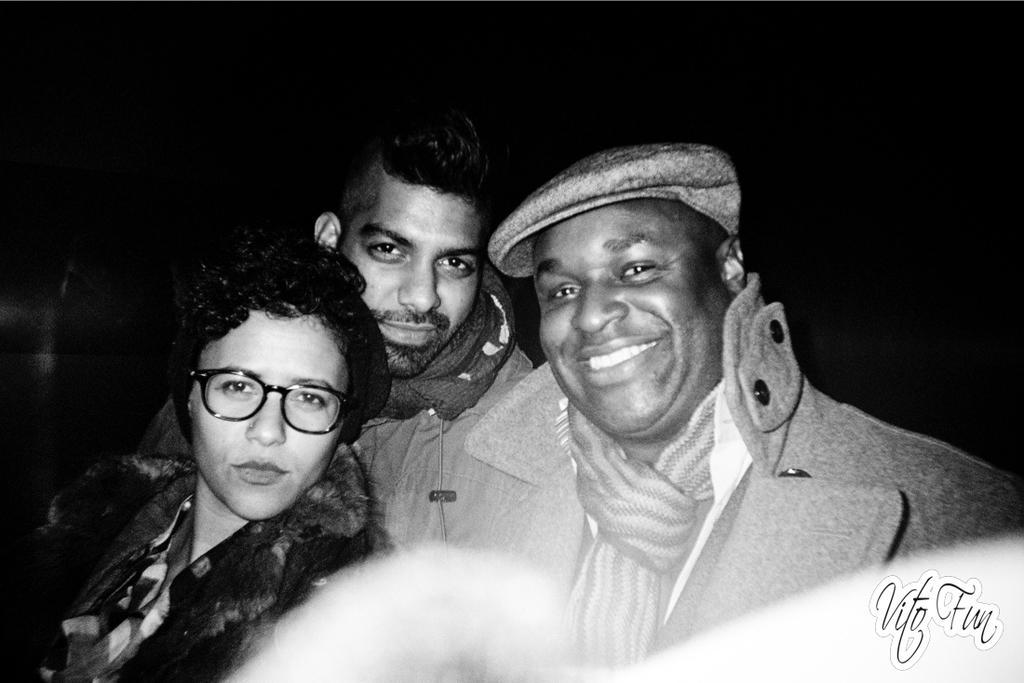How would you summarize this image in a sentence or two? It is the black and white image in which there are three persons. On the right side there is a man who is having a cap is wearing the jacket and a scarf. On the left side there is another person who is having a spects. 